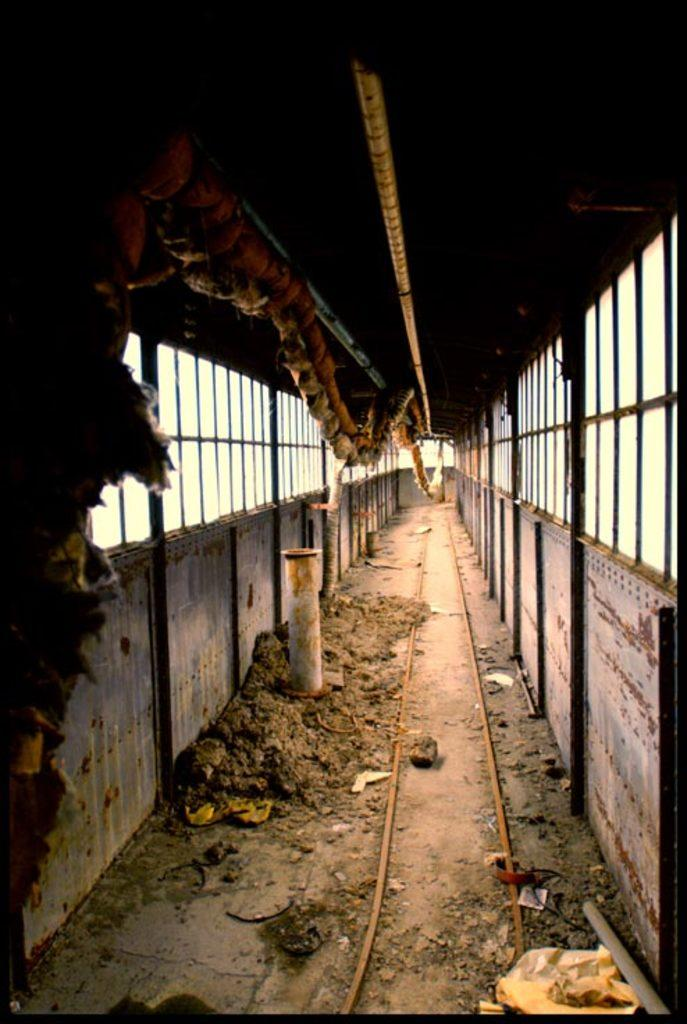What is the main object in the center of the image? There is a rod in the center of the image. What is attached to the top of the rod? There are ropes at the top of the rod. What can be seen in the background of the image? There are windows visible in the background of the image. How many bricks are being carried by the flock of birds in the image? There are no birds or bricks present in the image. 